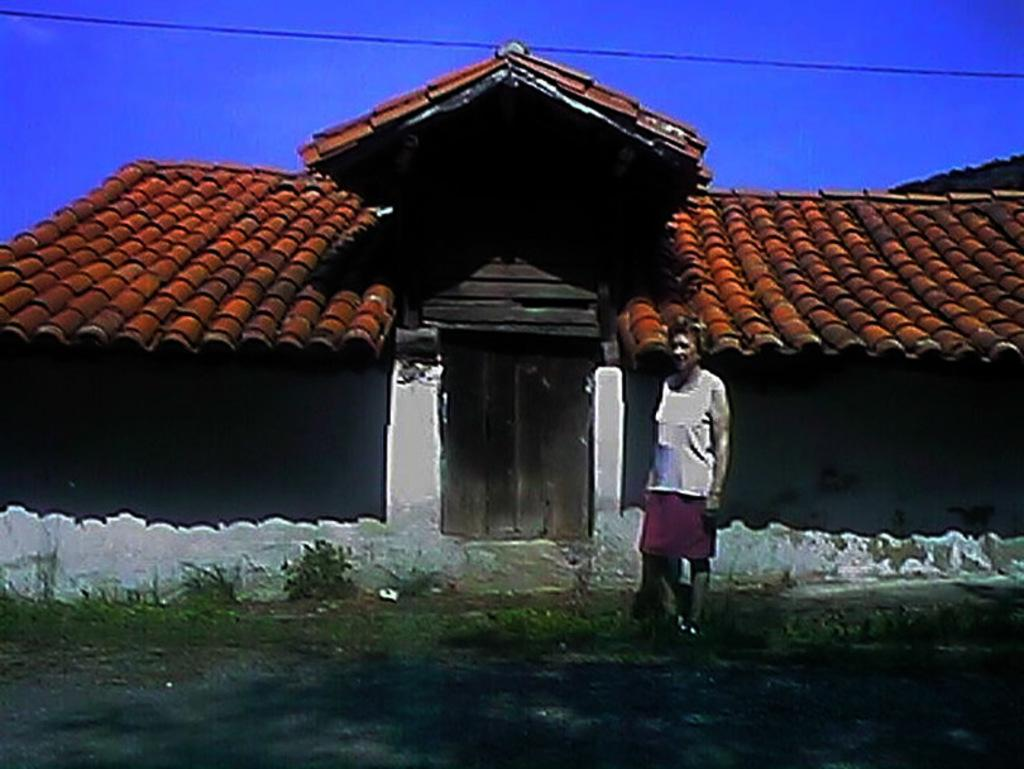What is the main subject of the image? There is a person standing in the image. What can be seen in the background of the image? There is a house, plants, a wire, and the sky visible in the background of the image. How many hours does the pipe in the image have? There is no pipe present in the image, so it is not possible to determine the number of hours it has. 